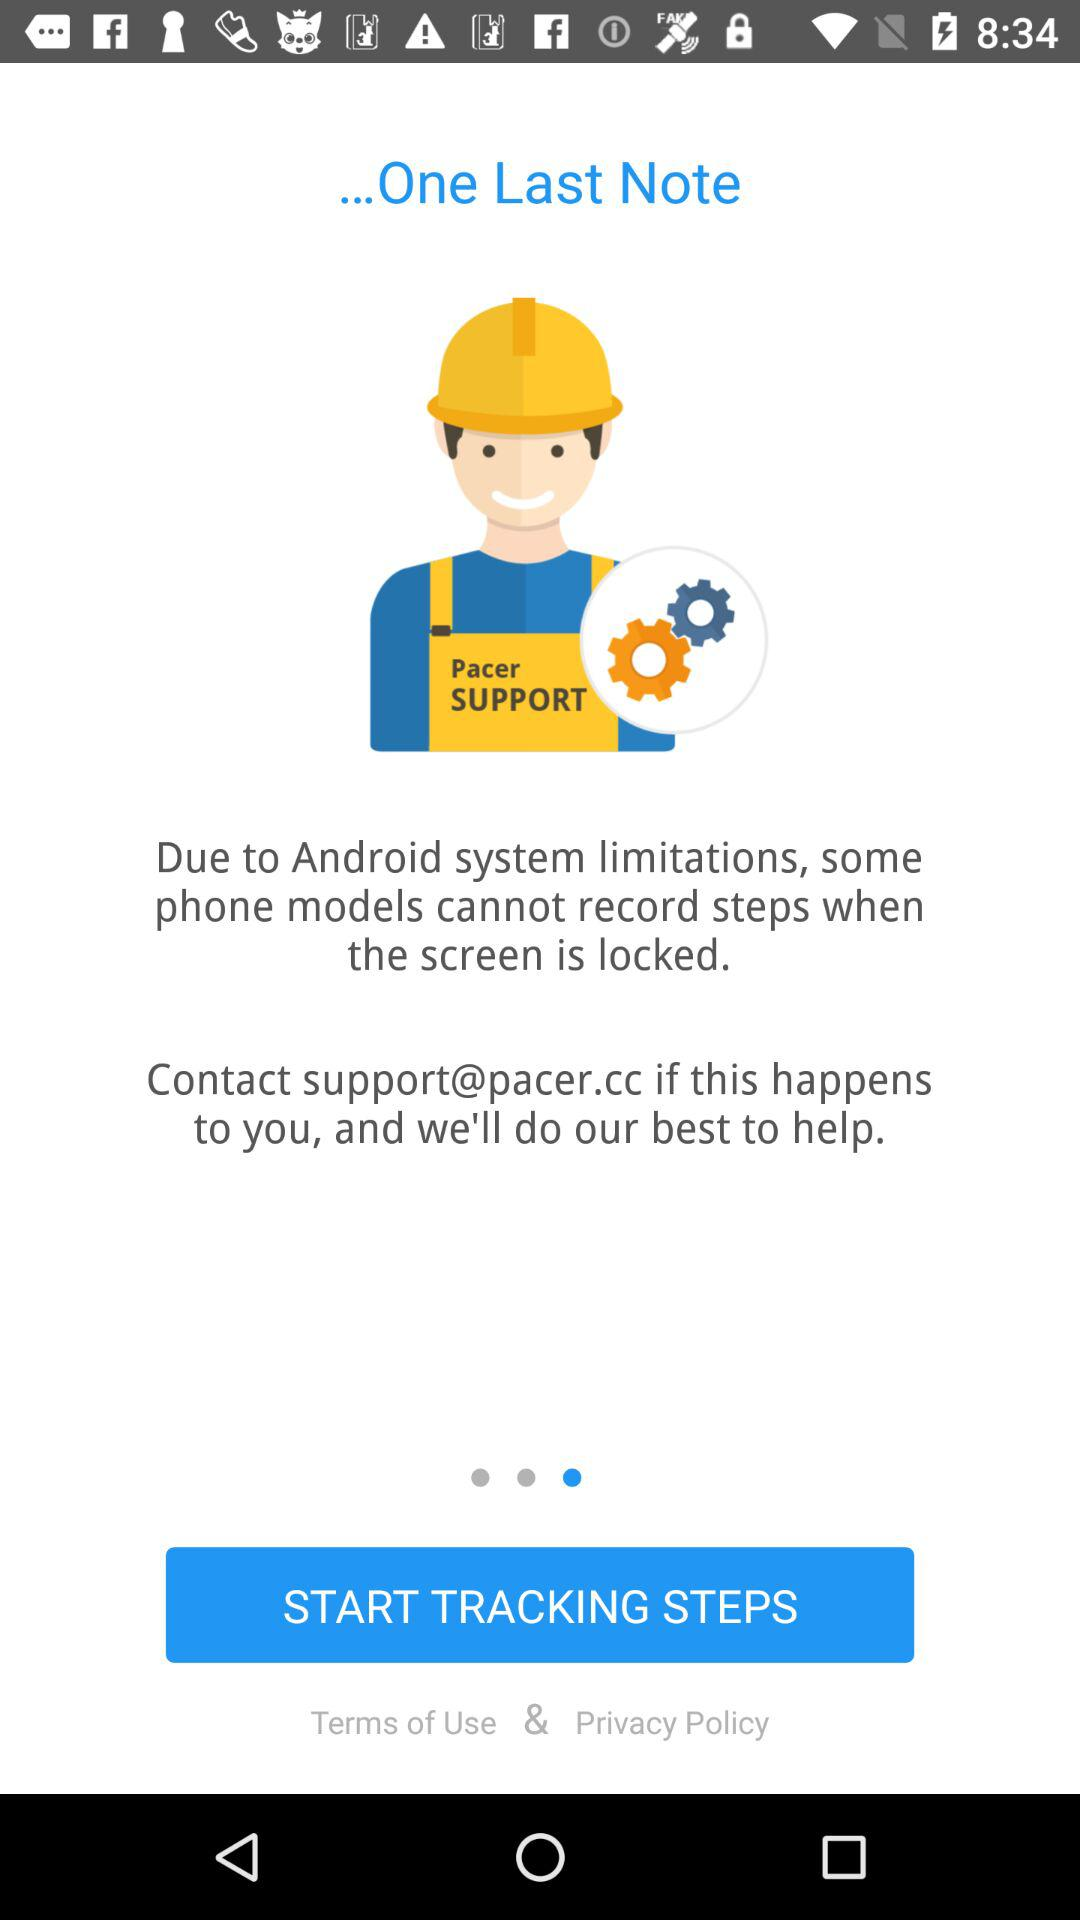What is the email address I can use if I have any problems? You can use support@pacer.cc if you have any problems. 